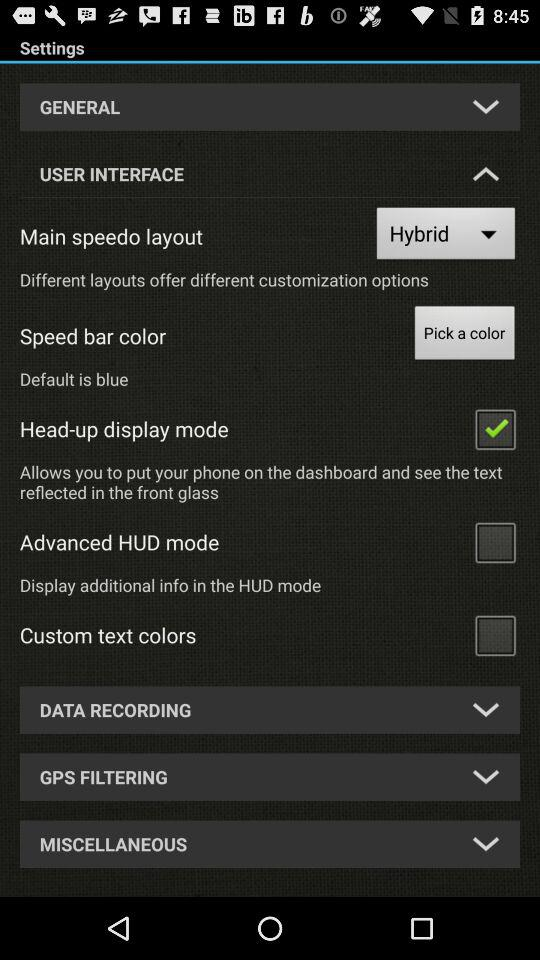Which settings are unchecked? The settings are "Advanced HUD mode", "Custom text colors". 